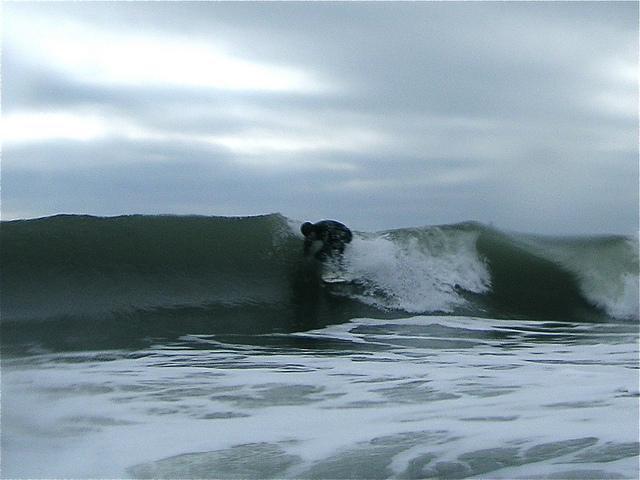How many elephant are facing the right side of the image?
Give a very brief answer. 0. 